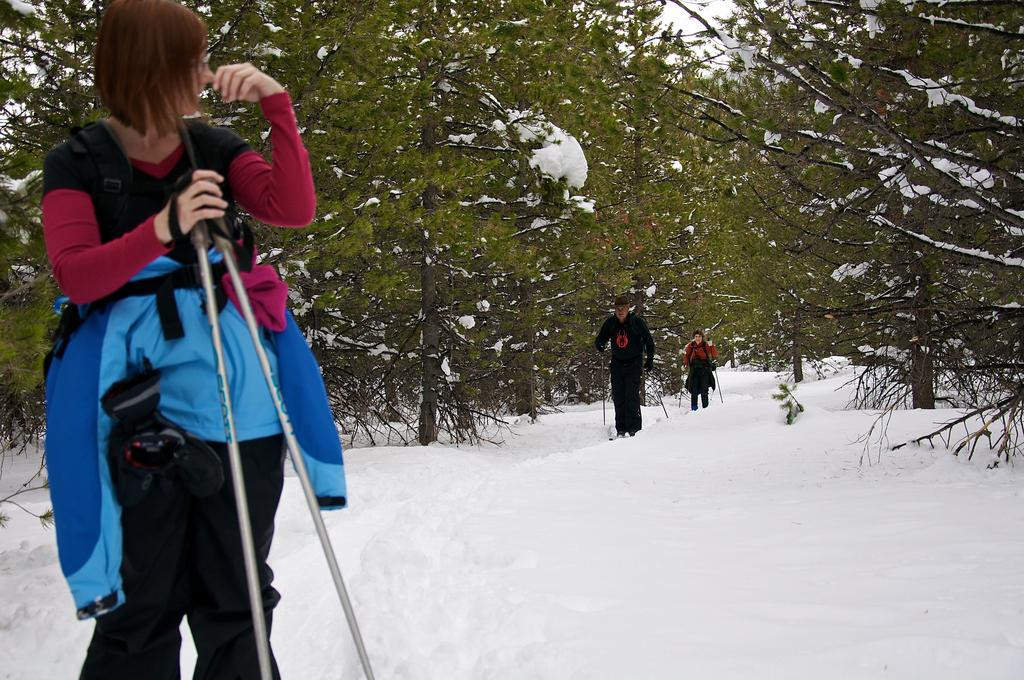What is the main subject in the foreground of the image? There is a person standing in the foreground of the image. What type of weather condition is depicted in the image? There is snow at the bottom of the image. What can be seen in the background of the image? There are trees and other persons in the background of the image. What type of suit is the person wearing in the image? The provided facts do not mention any clothing, including a suit, so we cannot determine if the person is wearing a suit. 